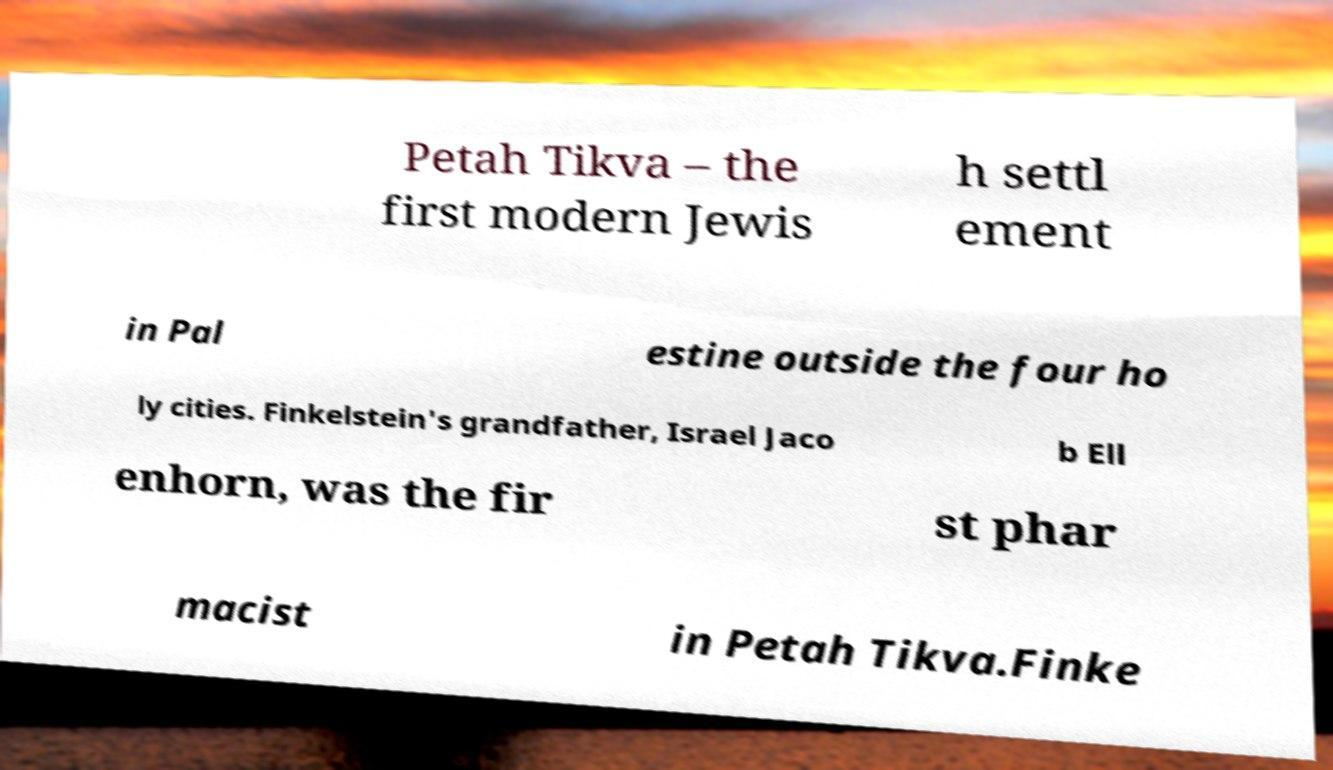I need the written content from this picture converted into text. Can you do that? Petah Tikva – the first modern Jewis h settl ement in Pal estine outside the four ho ly cities. Finkelstein's grandfather, Israel Jaco b Ell enhorn, was the fir st phar macist in Petah Tikva.Finke 